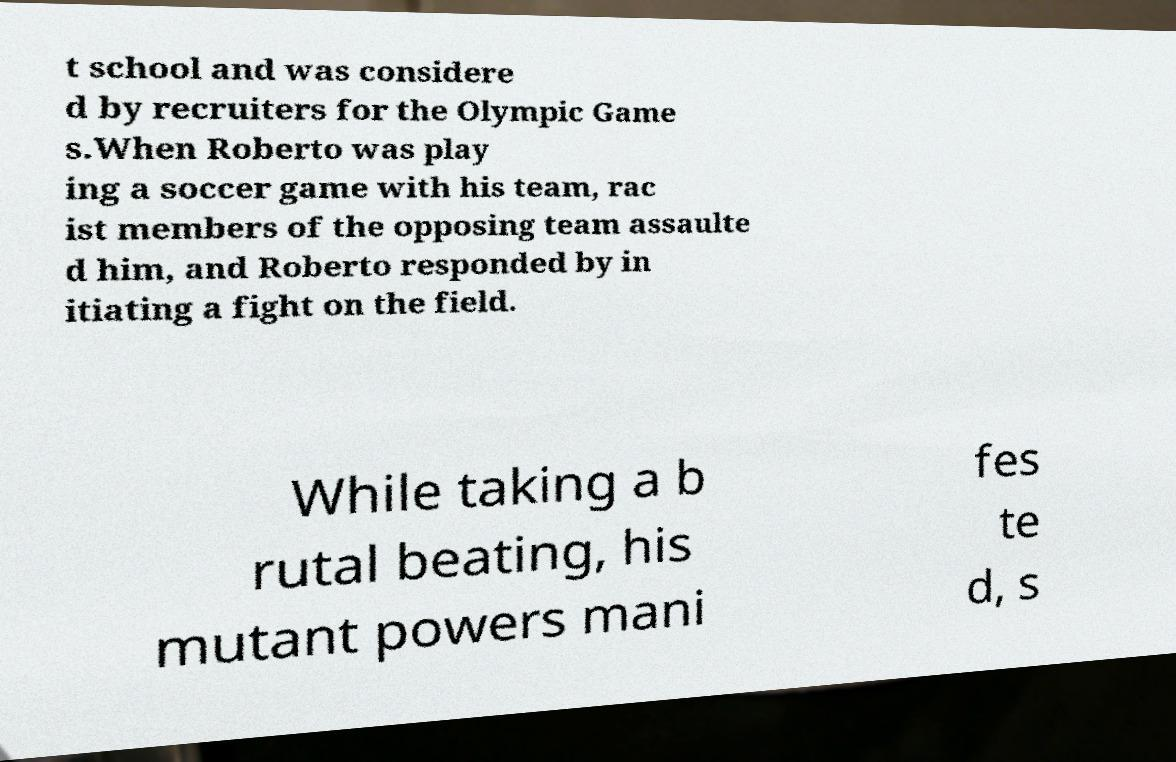Could you extract and type out the text from this image? t school and was considere d by recruiters for the Olympic Game s.When Roberto was play ing a soccer game with his team, rac ist members of the opposing team assaulte d him, and Roberto responded by in itiating a fight on the field. While taking a b rutal beating, his mutant powers mani fes te d, s 